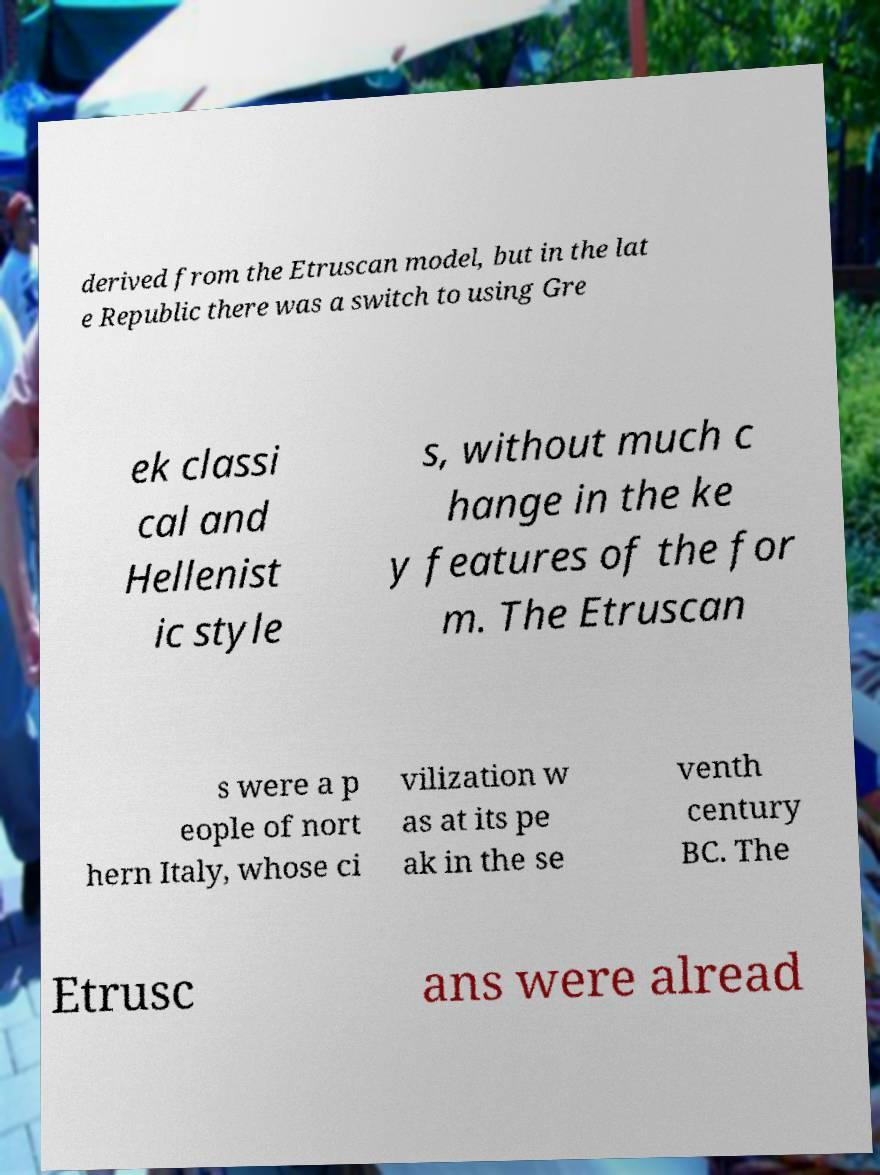Please identify and transcribe the text found in this image. derived from the Etruscan model, but in the lat e Republic there was a switch to using Gre ek classi cal and Hellenist ic style s, without much c hange in the ke y features of the for m. The Etruscan s were a p eople of nort hern Italy, whose ci vilization w as at its pe ak in the se venth century BC. The Etrusc ans were alread 